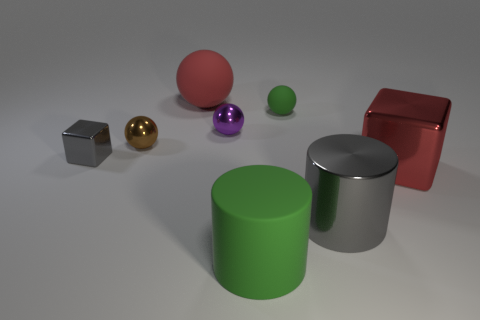Subtract all large rubber spheres. How many spheres are left? 3 Subtract all purple spheres. How many spheres are left? 3 Add 1 small red cylinders. How many objects exist? 9 Subtract all cubes. How many objects are left? 6 Subtract all gray cylinders. Subtract all green cubes. How many cylinders are left? 1 Subtract all purple balls. How many red blocks are left? 1 Subtract all cyan metallic cylinders. Subtract all rubber cylinders. How many objects are left? 7 Add 2 brown metallic spheres. How many brown metallic spheres are left? 3 Add 1 tiny gray cubes. How many tiny gray cubes exist? 2 Subtract 0 brown blocks. How many objects are left? 8 